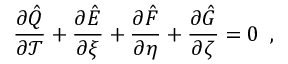<formula> <loc_0><loc_0><loc_500><loc_500>\frac { \partial \hat { Q } } { \partial \mathcal { T } } + \frac { \partial \hat { E } } { \partial \xi } + \frac { \partial \hat { F } } { \partial \eta } + \frac { \partial \hat { G } } { \partial \zeta } = 0 \, ,</formula> 